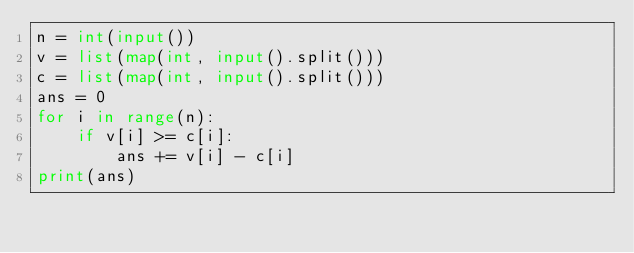Convert code to text. <code><loc_0><loc_0><loc_500><loc_500><_Python_>n = int(input())
v = list(map(int, input().split()))
c = list(map(int, input().split()))
ans = 0
for i in range(n):
    if v[i] >= c[i]:
        ans += v[i] - c[i]
print(ans)</code> 